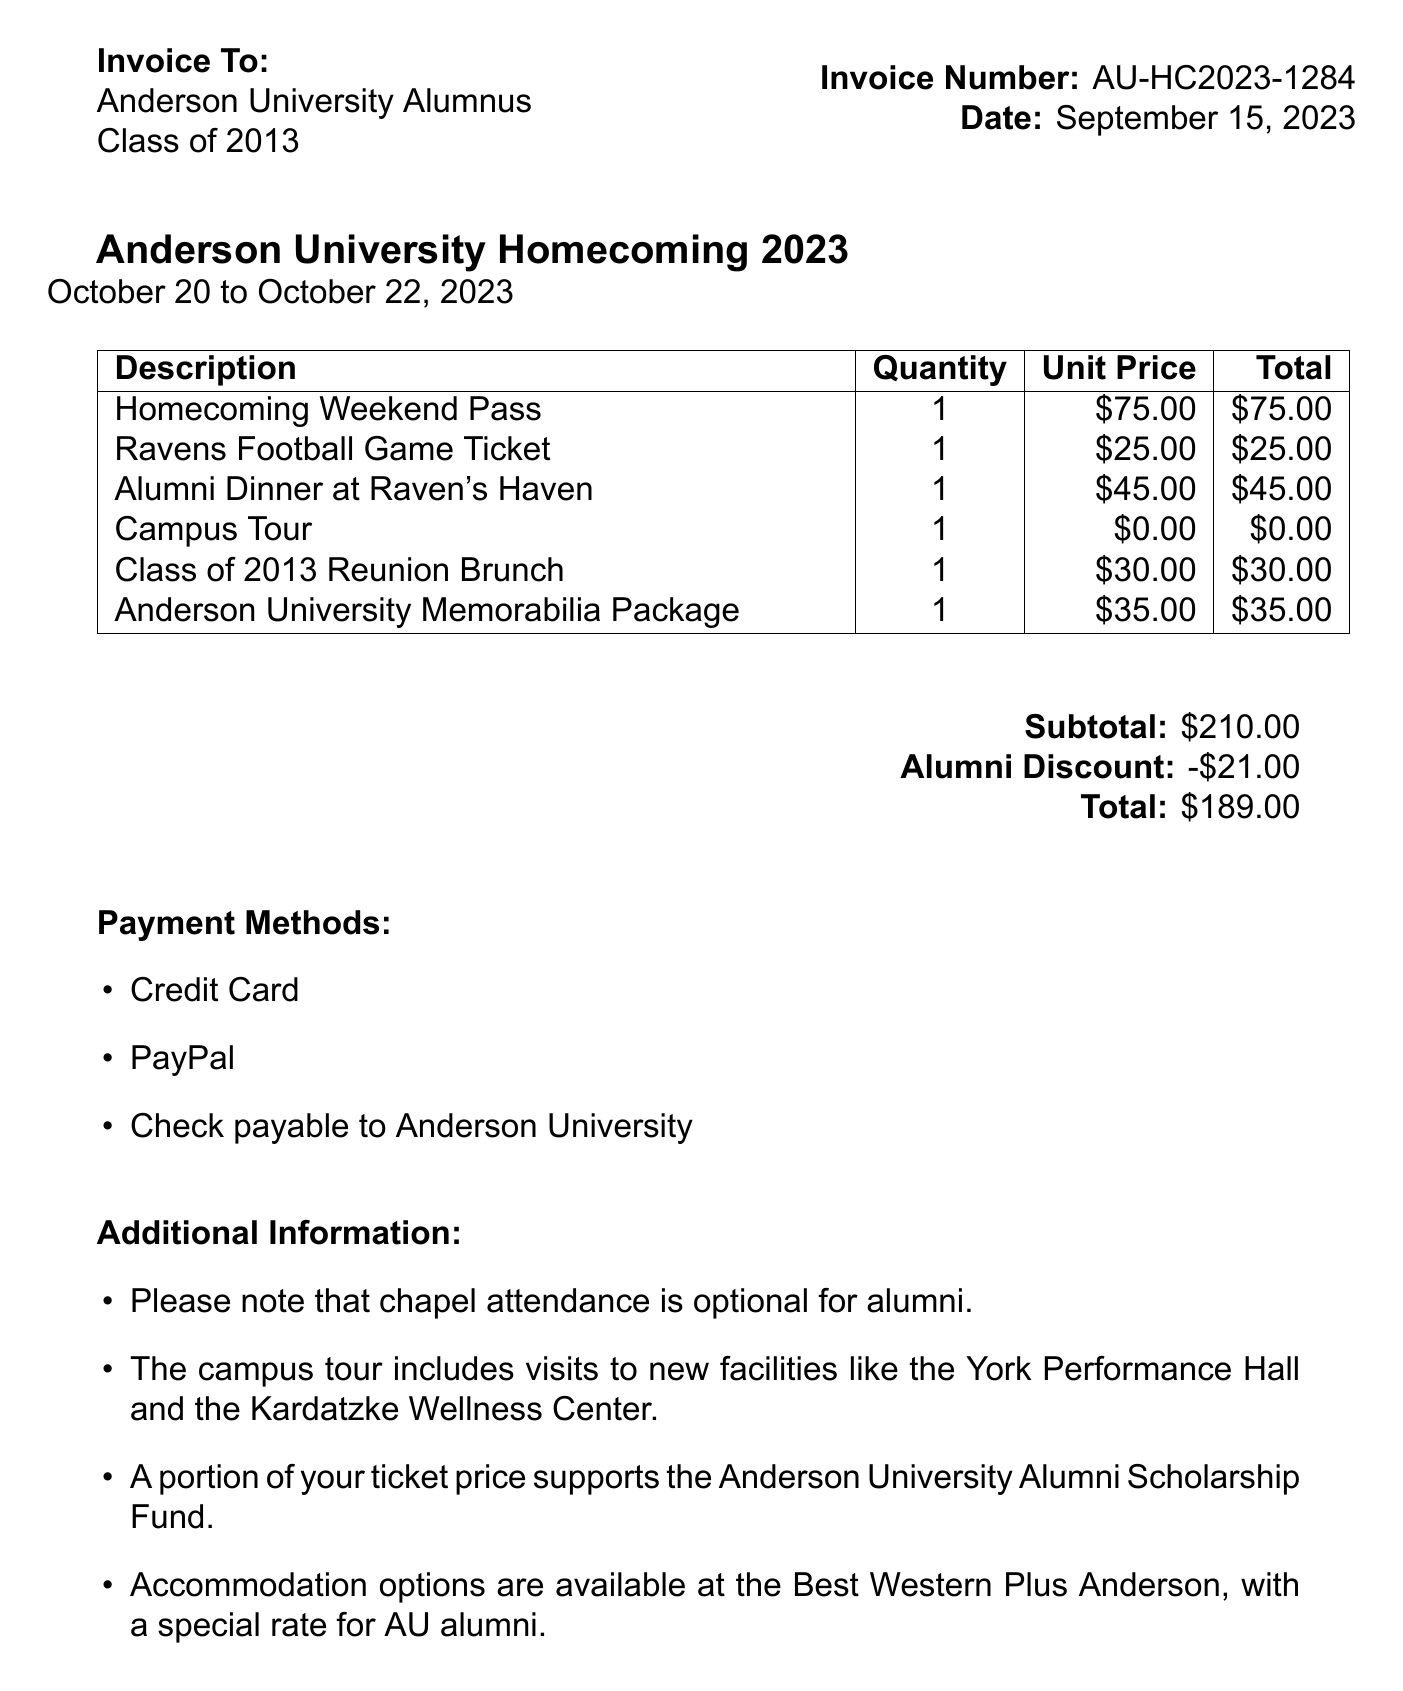What is the invoice number? The invoice number is stated prominently as part of the invoice details.
Answer: AU-HC2023-1284 What is the date of the invoice? The date is clearly listed under the invoice number and other details.
Answer: September 15, 2023 What is the total amount due? The total amount is presented at the bottom of the invoice summary section.
Answer: $189.00 How much is the alumni discount? The alumni discount is clearly specified as a subtraction amount in the invoice.
Answer: -$21.00 What is included in the Homecoming Weekend Pass? It can be inferred that the pass enables participation in several weekend events, hence included activities.
Answer: Homecoming Weekend events What are the payment methods? The document lists the acceptable payment methods specifically for this invoice.
Answer: Credit Card, PayPal, Check payable to Anderson University What event does this invoice pertain to? The event name is mentioned at the beginning of the document as the main focus of the invoice.
Answer: Anderson University Homecoming 2023 What is the date range for the event? The date range is stated directly beneath the event name in the invoice details.
Answer: October 20 to October 22, 2023 Is chapel attendance mandatory? The document specifies the nature of chapel attendance for alumni.
Answer: Optional Where can alumni find accommodation? The additional info section provides details about accommodation options.
Answer: Best Western Plus Anderson 